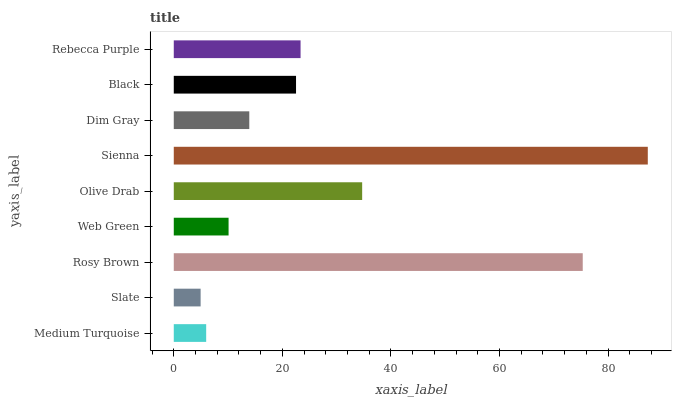Is Slate the minimum?
Answer yes or no. Yes. Is Sienna the maximum?
Answer yes or no. Yes. Is Rosy Brown the minimum?
Answer yes or no. No. Is Rosy Brown the maximum?
Answer yes or no. No. Is Rosy Brown greater than Slate?
Answer yes or no. Yes. Is Slate less than Rosy Brown?
Answer yes or no. Yes. Is Slate greater than Rosy Brown?
Answer yes or no. No. Is Rosy Brown less than Slate?
Answer yes or no. No. Is Black the high median?
Answer yes or no. Yes. Is Black the low median?
Answer yes or no. Yes. Is Rebecca Purple the high median?
Answer yes or no. No. Is Slate the low median?
Answer yes or no. No. 